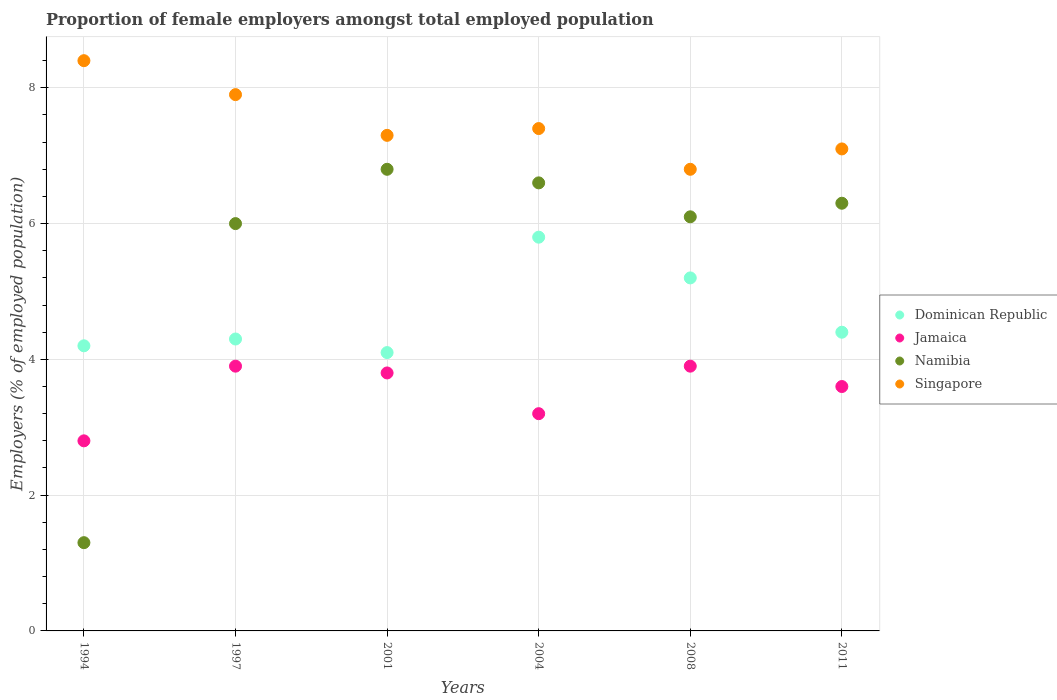Is the number of dotlines equal to the number of legend labels?
Offer a very short reply. Yes. What is the proportion of female employers in Jamaica in 1997?
Provide a succinct answer. 3.9. Across all years, what is the maximum proportion of female employers in Jamaica?
Your answer should be compact. 3.9. Across all years, what is the minimum proportion of female employers in Jamaica?
Ensure brevity in your answer.  2.8. What is the total proportion of female employers in Namibia in the graph?
Ensure brevity in your answer.  33.1. What is the difference between the proportion of female employers in Jamaica in 2004 and that in 2011?
Keep it short and to the point. -0.4. What is the difference between the proportion of female employers in Singapore in 1997 and the proportion of female employers in Jamaica in 2001?
Your response must be concise. 4.1. What is the average proportion of female employers in Dominican Republic per year?
Your answer should be compact. 4.67. In the year 2008, what is the difference between the proportion of female employers in Dominican Republic and proportion of female employers in Singapore?
Make the answer very short. -1.6. In how many years, is the proportion of female employers in Jamaica greater than 1.2000000000000002 %?
Provide a short and direct response. 6. What is the ratio of the proportion of female employers in Namibia in 2001 to that in 2008?
Offer a terse response. 1.11. What is the difference between the highest and the lowest proportion of female employers in Namibia?
Offer a very short reply. 5.5. Is the sum of the proportion of female employers in Singapore in 1994 and 1997 greater than the maximum proportion of female employers in Dominican Republic across all years?
Provide a succinct answer. Yes. Does the proportion of female employers in Singapore monotonically increase over the years?
Provide a short and direct response. No. Is the proportion of female employers in Singapore strictly greater than the proportion of female employers in Dominican Republic over the years?
Offer a terse response. Yes. How many dotlines are there?
Provide a short and direct response. 4. How many years are there in the graph?
Provide a succinct answer. 6. Does the graph contain any zero values?
Offer a terse response. No. Does the graph contain grids?
Make the answer very short. Yes. How are the legend labels stacked?
Your response must be concise. Vertical. What is the title of the graph?
Offer a terse response. Proportion of female employers amongst total employed population. Does "New Zealand" appear as one of the legend labels in the graph?
Keep it short and to the point. No. What is the label or title of the X-axis?
Your response must be concise. Years. What is the label or title of the Y-axis?
Your answer should be very brief. Employers (% of employed population). What is the Employers (% of employed population) of Dominican Republic in 1994?
Make the answer very short. 4.2. What is the Employers (% of employed population) in Jamaica in 1994?
Ensure brevity in your answer.  2.8. What is the Employers (% of employed population) in Namibia in 1994?
Provide a succinct answer. 1.3. What is the Employers (% of employed population) in Singapore in 1994?
Provide a succinct answer. 8.4. What is the Employers (% of employed population) of Dominican Republic in 1997?
Give a very brief answer. 4.3. What is the Employers (% of employed population) of Jamaica in 1997?
Your answer should be compact. 3.9. What is the Employers (% of employed population) of Namibia in 1997?
Make the answer very short. 6. What is the Employers (% of employed population) of Singapore in 1997?
Give a very brief answer. 7.9. What is the Employers (% of employed population) in Dominican Republic in 2001?
Provide a succinct answer. 4.1. What is the Employers (% of employed population) in Jamaica in 2001?
Give a very brief answer. 3.8. What is the Employers (% of employed population) in Namibia in 2001?
Your response must be concise. 6.8. What is the Employers (% of employed population) in Singapore in 2001?
Your answer should be very brief. 7.3. What is the Employers (% of employed population) of Dominican Republic in 2004?
Provide a short and direct response. 5.8. What is the Employers (% of employed population) of Jamaica in 2004?
Offer a very short reply. 3.2. What is the Employers (% of employed population) in Namibia in 2004?
Your response must be concise. 6.6. What is the Employers (% of employed population) of Singapore in 2004?
Your answer should be compact. 7.4. What is the Employers (% of employed population) in Dominican Republic in 2008?
Offer a very short reply. 5.2. What is the Employers (% of employed population) in Jamaica in 2008?
Provide a succinct answer. 3.9. What is the Employers (% of employed population) in Namibia in 2008?
Give a very brief answer. 6.1. What is the Employers (% of employed population) of Singapore in 2008?
Your answer should be very brief. 6.8. What is the Employers (% of employed population) of Dominican Republic in 2011?
Your response must be concise. 4.4. What is the Employers (% of employed population) in Jamaica in 2011?
Provide a short and direct response. 3.6. What is the Employers (% of employed population) of Namibia in 2011?
Your answer should be very brief. 6.3. What is the Employers (% of employed population) of Singapore in 2011?
Provide a short and direct response. 7.1. Across all years, what is the maximum Employers (% of employed population) of Dominican Republic?
Make the answer very short. 5.8. Across all years, what is the maximum Employers (% of employed population) in Jamaica?
Ensure brevity in your answer.  3.9. Across all years, what is the maximum Employers (% of employed population) in Namibia?
Your response must be concise. 6.8. Across all years, what is the maximum Employers (% of employed population) in Singapore?
Give a very brief answer. 8.4. Across all years, what is the minimum Employers (% of employed population) in Dominican Republic?
Make the answer very short. 4.1. Across all years, what is the minimum Employers (% of employed population) of Jamaica?
Provide a short and direct response. 2.8. Across all years, what is the minimum Employers (% of employed population) of Namibia?
Make the answer very short. 1.3. Across all years, what is the minimum Employers (% of employed population) in Singapore?
Your response must be concise. 6.8. What is the total Employers (% of employed population) in Jamaica in the graph?
Keep it short and to the point. 21.2. What is the total Employers (% of employed population) in Namibia in the graph?
Your response must be concise. 33.1. What is the total Employers (% of employed population) in Singapore in the graph?
Provide a succinct answer. 44.9. What is the difference between the Employers (% of employed population) in Dominican Republic in 1994 and that in 1997?
Give a very brief answer. -0.1. What is the difference between the Employers (% of employed population) in Jamaica in 1994 and that in 1997?
Your answer should be very brief. -1.1. What is the difference between the Employers (% of employed population) of Dominican Republic in 1994 and that in 2001?
Keep it short and to the point. 0.1. What is the difference between the Employers (% of employed population) of Singapore in 1994 and that in 2001?
Offer a very short reply. 1.1. What is the difference between the Employers (% of employed population) in Dominican Republic in 1994 and that in 2004?
Your answer should be compact. -1.6. What is the difference between the Employers (% of employed population) in Jamaica in 1994 and that in 2004?
Ensure brevity in your answer.  -0.4. What is the difference between the Employers (% of employed population) of Singapore in 1994 and that in 2004?
Provide a short and direct response. 1. What is the difference between the Employers (% of employed population) in Dominican Republic in 1994 and that in 2008?
Provide a short and direct response. -1. What is the difference between the Employers (% of employed population) of Namibia in 1994 and that in 2008?
Make the answer very short. -4.8. What is the difference between the Employers (% of employed population) of Jamaica in 1994 and that in 2011?
Offer a very short reply. -0.8. What is the difference between the Employers (% of employed population) of Namibia in 1994 and that in 2011?
Your response must be concise. -5. What is the difference between the Employers (% of employed population) of Dominican Republic in 1997 and that in 2001?
Your answer should be compact. 0.2. What is the difference between the Employers (% of employed population) of Jamaica in 1997 and that in 2004?
Provide a succinct answer. 0.7. What is the difference between the Employers (% of employed population) of Namibia in 1997 and that in 2004?
Keep it short and to the point. -0.6. What is the difference between the Employers (% of employed population) in Dominican Republic in 1997 and that in 2011?
Your response must be concise. -0.1. What is the difference between the Employers (% of employed population) in Jamaica in 1997 and that in 2011?
Make the answer very short. 0.3. What is the difference between the Employers (% of employed population) in Namibia in 2001 and that in 2004?
Your answer should be compact. 0.2. What is the difference between the Employers (% of employed population) in Singapore in 2001 and that in 2004?
Your answer should be very brief. -0.1. What is the difference between the Employers (% of employed population) in Dominican Republic in 2001 and that in 2008?
Offer a terse response. -1.1. What is the difference between the Employers (% of employed population) in Singapore in 2001 and that in 2008?
Give a very brief answer. 0.5. What is the difference between the Employers (% of employed population) in Dominican Republic in 2001 and that in 2011?
Provide a succinct answer. -0.3. What is the difference between the Employers (% of employed population) of Jamaica in 2001 and that in 2011?
Keep it short and to the point. 0.2. What is the difference between the Employers (% of employed population) of Namibia in 2001 and that in 2011?
Provide a short and direct response. 0.5. What is the difference between the Employers (% of employed population) in Jamaica in 2004 and that in 2008?
Your response must be concise. -0.7. What is the difference between the Employers (% of employed population) in Singapore in 2004 and that in 2008?
Make the answer very short. 0.6. What is the difference between the Employers (% of employed population) in Jamaica in 2004 and that in 2011?
Make the answer very short. -0.4. What is the difference between the Employers (% of employed population) of Namibia in 2004 and that in 2011?
Provide a short and direct response. 0.3. What is the difference between the Employers (% of employed population) of Singapore in 2004 and that in 2011?
Your response must be concise. 0.3. What is the difference between the Employers (% of employed population) in Jamaica in 2008 and that in 2011?
Ensure brevity in your answer.  0.3. What is the difference between the Employers (% of employed population) in Namibia in 2008 and that in 2011?
Offer a terse response. -0.2. What is the difference between the Employers (% of employed population) in Dominican Republic in 1994 and the Employers (% of employed population) in Namibia in 1997?
Provide a short and direct response. -1.8. What is the difference between the Employers (% of employed population) in Dominican Republic in 1994 and the Employers (% of employed population) in Jamaica in 2001?
Ensure brevity in your answer.  0.4. What is the difference between the Employers (% of employed population) in Namibia in 1994 and the Employers (% of employed population) in Singapore in 2001?
Give a very brief answer. -6. What is the difference between the Employers (% of employed population) in Dominican Republic in 1994 and the Employers (% of employed population) in Singapore in 2004?
Give a very brief answer. -3.2. What is the difference between the Employers (% of employed population) of Namibia in 1994 and the Employers (% of employed population) of Singapore in 2004?
Ensure brevity in your answer.  -6.1. What is the difference between the Employers (% of employed population) in Dominican Republic in 1994 and the Employers (% of employed population) in Namibia in 2008?
Make the answer very short. -1.9. What is the difference between the Employers (% of employed population) in Jamaica in 1994 and the Employers (% of employed population) in Namibia in 2008?
Offer a very short reply. -3.3. What is the difference between the Employers (% of employed population) in Jamaica in 1994 and the Employers (% of employed population) in Singapore in 2008?
Your answer should be compact. -4. What is the difference between the Employers (% of employed population) of Namibia in 1994 and the Employers (% of employed population) of Singapore in 2008?
Keep it short and to the point. -5.5. What is the difference between the Employers (% of employed population) in Dominican Republic in 1994 and the Employers (% of employed population) in Jamaica in 2011?
Provide a succinct answer. 0.6. What is the difference between the Employers (% of employed population) of Dominican Republic in 1994 and the Employers (% of employed population) of Singapore in 2011?
Provide a short and direct response. -2.9. What is the difference between the Employers (% of employed population) of Jamaica in 1994 and the Employers (% of employed population) of Namibia in 2011?
Make the answer very short. -3.5. What is the difference between the Employers (% of employed population) of Jamaica in 1994 and the Employers (% of employed population) of Singapore in 2011?
Your response must be concise. -4.3. What is the difference between the Employers (% of employed population) of Namibia in 1994 and the Employers (% of employed population) of Singapore in 2011?
Your answer should be compact. -5.8. What is the difference between the Employers (% of employed population) of Dominican Republic in 1997 and the Employers (% of employed population) of Jamaica in 2001?
Offer a very short reply. 0.5. What is the difference between the Employers (% of employed population) in Dominican Republic in 1997 and the Employers (% of employed population) in Namibia in 2001?
Keep it short and to the point. -2.5. What is the difference between the Employers (% of employed population) in Dominican Republic in 1997 and the Employers (% of employed population) in Singapore in 2001?
Your answer should be compact. -3. What is the difference between the Employers (% of employed population) of Jamaica in 1997 and the Employers (% of employed population) of Singapore in 2001?
Keep it short and to the point. -3.4. What is the difference between the Employers (% of employed population) in Namibia in 1997 and the Employers (% of employed population) in Singapore in 2001?
Offer a very short reply. -1.3. What is the difference between the Employers (% of employed population) of Jamaica in 1997 and the Employers (% of employed population) of Namibia in 2004?
Your answer should be compact. -2.7. What is the difference between the Employers (% of employed population) of Jamaica in 1997 and the Employers (% of employed population) of Singapore in 2004?
Offer a terse response. -3.5. What is the difference between the Employers (% of employed population) of Dominican Republic in 1997 and the Employers (% of employed population) of Namibia in 2008?
Your answer should be compact. -1.8. What is the difference between the Employers (% of employed population) in Dominican Republic in 1997 and the Employers (% of employed population) in Jamaica in 2011?
Keep it short and to the point. 0.7. What is the difference between the Employers (% of employed population) of Dominican Republic in 1997 and the Employers (% of employed population) of Namibia in 2011?
Give a very brief answer. -2. What is the difference between the Employers (% of employed population) of Dominican Republic in 1997 and the Employers (% of employed population) of Singapore in 2011?
Give a very brief answer. -2.8. What is the difference between the Employers (% of employed population) of Jamaica in 1997 and the Employers (% of employed population) of Singapore in 2011?
Give a very brief answer. -3.2. What is the difference between the Employers (% of employed population) of Namibia in 1997 and the Employers (% of employed population) of Singapore in 2011?
Keep it short and to the point. -1.1. What is the difference between the Employers (% of employed population) in Dominican Republic in 2001 and the Employers (% of employed population) in Jamaica in 2004?
Offer a very short reply. 0.9. What is the difference between the Employers (% of employed population) of Dominican Republic in 2001 and the Employers (% of employed population) of Singapore in 2004?
Your answer should be very brief. -3.3. What is the difference between the Employers (% of employed population) of Jamaica in 2001 and the Employers (% of employed population) of Namibia in 2004?
Provide a succinct answer. -2.8. What is the difference between the Employers (% of employed population) in Dominican Republic in 2001 and the Employers (% of employed population) in Singapore in 2008?
Make the answer very short. -2.7. What is the difference between the Employers (% of employed population) in Jamaica in 2001 and the Employers (% of employed population) in Namibia in 2008?
Offer a terse response. -2.3. What is the difference between the Employers (% of employed population) of Jamaica in 2001 and the Employers (% of employed population) of Singapore in 2008?
Your answer should be compact. -3. What is the difference between the Employers (% of employed population) of Namibia in 2001 and the Employers (% of employed population) of Singapore in 2008?
Give a very brief answer. 0. What is the difference between the Employers (% of employed population) of Dominican Republic in 2001 and the Employers (% of employed population) of Namibia in 2011?
Provide a succinct answer. -2.2. What is the difference between the Employers (% of employed population) of Dominican Republic in 2001 and the Employers (% of employed population) of Singapore in 2011?
Your answer should be very brief. -3. What is the difference between the Employers (% of employed population) of Dominican Republic in 2004 and the Employers (% of employed population) of Jamaica in 2008?
Your response must be concise. 1.9. What is the difference between the Employers (% of employed population) of Dominican Republic in 2004 and the Employers (% of employed population) of Namibia in 2008?
Provide a succinct answer. -0.3. What is the difference between the Employers (% of employed population) of Dominican Republic in 2004 and the Employers (% of employed population) of Singapore in 2008?
Make the answer very short. -1. What is the difference between the Employers (% of employed population) of Jamaica in 2004 and the Employers (% of employed population) of Namibia in 2008?
Provide a short and direct response. -2.9. What is the difference between the Employers (% of employed population) of Dominican Republic in 2004 and the Employers (% of employed population) of Namibia in 2011?
Provide a short and direct response. -0.5. What is the difference between the Employers (% of employed population) of Jamaica in 2004 and the Employers (% of employed population) of Namibia in 2011?
Provide a short and direct response. -3.1. What is the difference between the Employers (% of employed population) in Jamaica in 2004 and the Employers (% of employed population) in Singapore in 2011?
Make the answer very short. -3.9. What is the difference between the Employers (% of employed population) of Dominican Republic in 2008 and the Employers (% of employed population) of Jamaica in 2011?
Your answer should be very brief. 1.6. What is the difference between the Employers (% of employed population) of Dominican Republic in 2008 and the Employers (% of employed population) of Namibia in 2011?
Offer a terse response. -1.1. What is the difference between the Employers (% of employed population) of Namibia in 2008 and the Employers (% of employed population) of Singapore in 2011?
Your response must be concise. -1. What is the average Employers (% of employed population) of Dominican Republic per year?
Your answer should be very brief. 4.67. What is the average Employers (% of employed population) in Jamaica per year?
Your answer should be compact. 3.53. What is the average Employers (% of employed population) in Namibia per year?
Keep it short and to the point. 5.52. What is the average Employers (% of employed population) in Singapore per year?
Keep it short and to the point. 7.48. In the year 1994, what is the difference between the Employers (% of employed population) of Dominican Republic and Employers (% of employed population) of Jamaica?
Provide a succinct answer. 1.4. In the year 1994, what is the difference between the Employers (% of employed population) of Dominican Republic and Employers (% of employed population) of Singapore?
Ensure brevity in your answer.  -4.2. In the year 1994, what is the difference between the Employers (% of employed population) of Jamaica and Employers (% of employed population) of Namibia?
Your answer should be very brief. 1.5. In the year 1994, what is the difference between the Employers (% of employed population) of Jamaica and Employers (% of employed population) of Singapore?
Make the answer very short. -5.6. In the year 1997, what is the difference between the Employers (% of employed population) of Dominican Republic and Employers (% of employed population) of Namibia?
Provide a short and direct response. -1.7. In the year 1997, what is the difference between the Employers (% of employed population) of Jamaica and Employers (% of employed population) of Namibia?
Provide a succinct answer. -2.1. In the year 1997, what is the difference between the Employers (% of employed population) of Jamaica and Employers (% of employed population) of Singapore?
Give a very brief answer. -4. In the year 2001, what is the difference between the Employers (% of employed population) of Dominican Republic and Employers (% of employed population) of Singapore?
Your answer should be very brief. -3.2. In the year 2004, what is the difference between the Employers (% of employed population) of Jamaica and Employers (% of employed population) of Namibia?
Provide a succinct answer. -3.4. In the year 2008, what is the difference between the Employers (% of employed population) in Dominican Republic and Employers (% of employed population) in Jamaica?
Give a very brief answer. 1.3. In the year 2008, what is the difference between the Employers (% of employed population) in Dominican Republic and Employers (% of employed population) in Namibia?
Give a very brief answer. -0.9. In the year 2008, what is the difference between the Employers (% of employed population) of Dominican Republic and Employers (% of employed population) of Singapore?
Keep it short and to the point. -1.6. In the year 2008, what is the difference between the Employers (% of employed population) in Jamaica and Employers (% of employed population) in Singapore?
Your answer should be compact. -2.9. In the year 2011, what is the difference between the Employers (% of employed population) of Dominican Republic and Employers (% of employed population) of Jamaica?
Your response must be concise. 0.8. In the year 2011, what is the difference between the Employers (% of employed population) of Dominican Republic and Employers (% of employed population) of Namibia?
Your response must be concise. -1.9. In the year 2011, what is the difference between the Employers (% of employed population) in Jamaica and Employers (% of employed population) in Singapore?
Offer a terse response. -3.5. What is the ratio of the Employers (% of employed population) of Dominican Republic in 1994 to that in 1997?
Your response must be concise. 0.98. What is the ratio of the Employers (% of employed population) in Jamaica in 1994 to that in 1997?
Ensure brevity in your answer.  0.72. What is the ratio of the Employers (% of employed population) of Namibia in 1994 to that in 1997?
Ensure brevity in your answer.  0.22. What is the ratio of the Employers (% of employed population) in Singapore in 1994 to that in 1997?
Give a very brief answer. 1.06. What is the ratio of the Employers (% of employed population) of Dominican Republic in 1994 to that in 2001?
Offer a terse response. 1.02. What is the ratio of the Employers (% of employed population) in Jamaica in 1994 to that in 2001?
Offer a terse response. 0.74. What is the ratio of the Employers (% of employed population) in Namibia in 1994 to that in 2001?
Give a very brief answer. 0.19. What is the ratio of the Employers (% of employed population) of Singapore in 1994 to that in 2001?
Make the answer very short. 1.15. What is the ratio of the Employers (% of employed population) in Dominican Republic in 1994 to that in 2004?
Your answer should be very brief. 0.72. What is the ratio of the Employers (% of employed population) in Jamaica in 1994 to that in 2004?
Your response must be concise. 0.88. What is the ratio of the Employers (% of employed population) in Namibia in 1994 to that in 2004?
Provide a short and direct response. 0.2. What is the ratio of the Employers (% of employed population) in Singapore in 1994 to that in 2004?
Keep it short and to the point. 1.14. What is the ratio of the Employers (% of employed population) in Dominican Republic in 1994 to that in 2008?
Your answer should be very brief. 0.81. What is the ratio of the Employers (% of employed population) in Jamaica in 1994 to that in 2008?
Give a very brief answer. 0.72. What is the ratio of the Employers (% of employed population) in Namibia in 1994 to that in 2008?
Provide a succinct answer. 0.21. What is the ratio of the Employers (% of employed population) in Singapore in 1994 to that in 2008?
Your answer should be very brief. 1.24. What is the ratio of the Employers (% of employed population) in Dominican Republic in 1994 to that in 2011?
Your answer should be compact. 0.95. What is the ratio of the Employers (% of employed population) of Namibia in 1994 to that in 2011?
Your answer should be compact. 0.21. What is the ratio of the Employers (% of employed population) in Singapore in 1994 to that in 2011?
Your answer should be very brief. 1.18. What is the ratio of the Employers (% of employed population) of Dominican Republic in 1997 to that in 2001?
Ensure brevity in your answer.  1.05. What is the ratio of the Employers (% of employed population) of Jamaica in 1997 to that in 2001?
Give a very brief answer. 1.03. What is the ratio of the Employers (% of employed population) in Namibia in 1997 to that in 2001?
Make the answer very short. 0.88. What is the ratio of the Employers (% of employed population) in Singapore in 1997 to that in 2001?
Give a very brief answer. 1.08. What is the ratio of the Employers (% of employed population) of Dominican Republic in 1997 to that in 2004?
Make the answer very short. 0.74. What is the ratio of the Employers (% of employed population) of Jamaica in 1997 to that in 2004?
Keep it short and to the point. 1.22. What is the ratio of the Employers (% of employed population) of Namibia in 1997 to that in 2004?
Your answer should be compact. 0.91. What is the ratio of the Employers (% of employed population) of Singapore in 1997 to that in 2004?
Keep it short and to the point. 1.07. What is the ratio of the Employers (% of employed population) of Dominican Republic in 1997 to that in 2008?
Your answer should be very brief. 0.83. What is the ratio of the Employers (% of employed population) in Jamaica in 1997 to that in 2008?
Give a very brief answer. 1. What is the ratio of the Employers (% of employed population) in Namibia in 1997 to that in 2008?
Give a very brief answer. 0.98. What is the ratio of the Employers (% of employed population) of Singapore in 1997 to that in 2008?
Provide a succinct answer. 1.16. What is the ratio of the Employers (% of employed population) in Dominican Republic in 1997 to that in 2011?
Your response must be concise. 0.98. What is the ratio of the Employers (% of employed population) of Jamaica in 1997 to that in 2011?
Ensure brevity in your answer.  1.08. What is the ratio of the Employers (% of employed population) in Namibia in 1997 to that in 2011?
Your answer should be very brief. 0.95. What is the ratio of the Employers (% of employed population) in Singapore in 1997 to that in 2011?
Offer a very short reply. 1.11. What is the ratio of the Employers (% of employed population) in Dominican Republic in 2001 to that in 2004?
Provide a short and direct response. 0.71. What is the ratio of the Employers (% of employed population) in Jamaica in 2001 to that in 2004?
Offer a very short reply. 1.19. What is the ratio of the Employers (% of employed population) of Namibia in 2001 to that in 2004?
Offer a terse response. 1.03. What is the ratio of the Employers (% of employed population) in Singapore in 2001 to that in 2004?
Your answer should be very brief. 0.99. What is the ratio of the Employers (% of employed population) of Dominican Republic in 2001 to that in 2008?
Offer a terse response. 0.79. What is the ratio of the Employers (% of employed population) in Jamaica in 2001 to that in 2008?
Provide a succinct answer. 0.97. What is the ratio of the Employers (% of employed population) in Namibia in 2001 to that in 2008?
Provide a short and direct response. 1.11. What is the ratio of the Employers (% of employed population) of Singapore in 2001 to that in 2008?
Your answer should be very brief. 1.07. What is the ratio of the Employers (% of employed population) in Dominican Republic in 2001 to that in 2011?
Provide a succinct answer. 0.93. What is the ratio of the Employers (% of employed population) of Jamaica in 2001 to that in 2011?
Your answer should be very brief. 1.06. What is the ratio of the Employers (% of employed population) of Namibia in 2001 to that in 2011?
Your response must be concise. 1.08. What is the ratio of the Employers (% of employed population) in Singapore in 2001 to that in 2011?
Keep it short and to the point. 1.03. What is the ratio of the Employers (% of employed population) in Dominican Republic in 2004 to that in 2008?
Make the answer very short. 1.12. What is the ratio of the Employers (% of employed population) in Jamaica in 2004 to that in 2008?
Your response must be concise. 0.82. What is the ratio of the Employers (% of employed population) of Namibia in 2004 to that in 2008?
Provide a short and direct response. 1.08. What is the ratio of the Employers (% of employed population) of Singapore in 2004 to that in 2008?
Make the answer very short. 1.09. What is the ratio of the Employers (% of employed population) in Dominican Republic in 2004 to that in 2011?
Ensure brevity in your answer.  1.32. What is the ratio of the Employers (% of employed population) in Namibia in 2004 to that in 2011?
Your response must be concise. 1.05. What is the ratio of the Employers (% of employed population) of Singapore in 2004 to that in 2011?
Keep it short and to the point. 1.04. What is the ratio of the Employers (% of employed population) in Dominican Republic in 2008 to that in 2011?
Make the answer very short. 1.18. What is the ratio of the Employers (% of employed population) of Namibia in 2008 to that in 2011?
Ensure brevity in your answer.  0.97. What is the ratio of the Employers (% of employed population) in Singapore in 2008 to that in 2011?
Your answer should be compact. 0.96. What is the difference between the highest and the second highest Employers (% of employed population) of Jamaica?
Offer a very short reply. 0. What is the difference between the highest and the lowest Employers (% of employed population) in Namibia?
Your answer should be compact. 5.5. What is the difference between the highest and the lowest Employers (% of employed population) in Singapore?
Offer a very short reply. 1.6. 